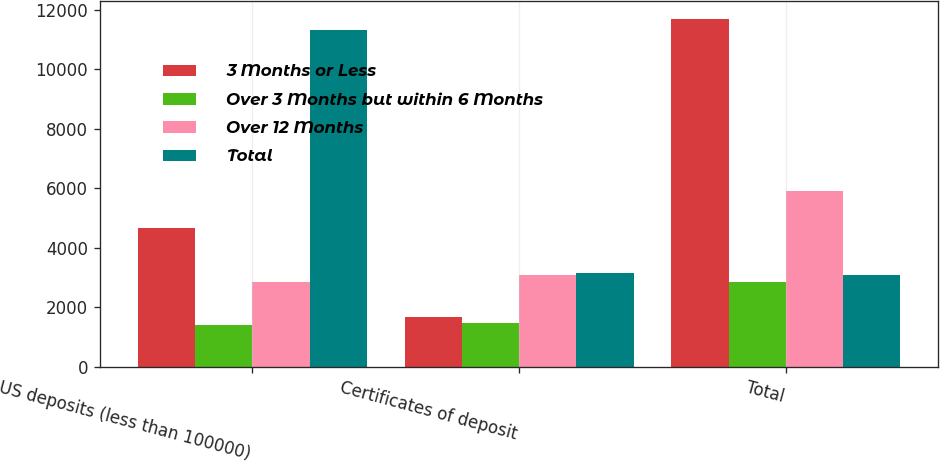Convert chart. <chart><loc_0><loc_0><loc_500><loc_500><stacked_bar_chart><ecel><fcel>US deposits (less than 100000)<fcel>Certificates of deposit<fcel>Total<nl><fcel>3 Months or Less<fcel>4677<fcel>1667<fcel>11708<nl><fcel>Over 3 Months but within 6 Months<fcel>1391<fcel>1465<fcel>2856<nl><fcel>Over 12 Months<fcel>2838<fcel>3077<fcel>5915<nl><fcel>Total<fcel>11320<fcel>3156<fcel>3077<nl></chart> 